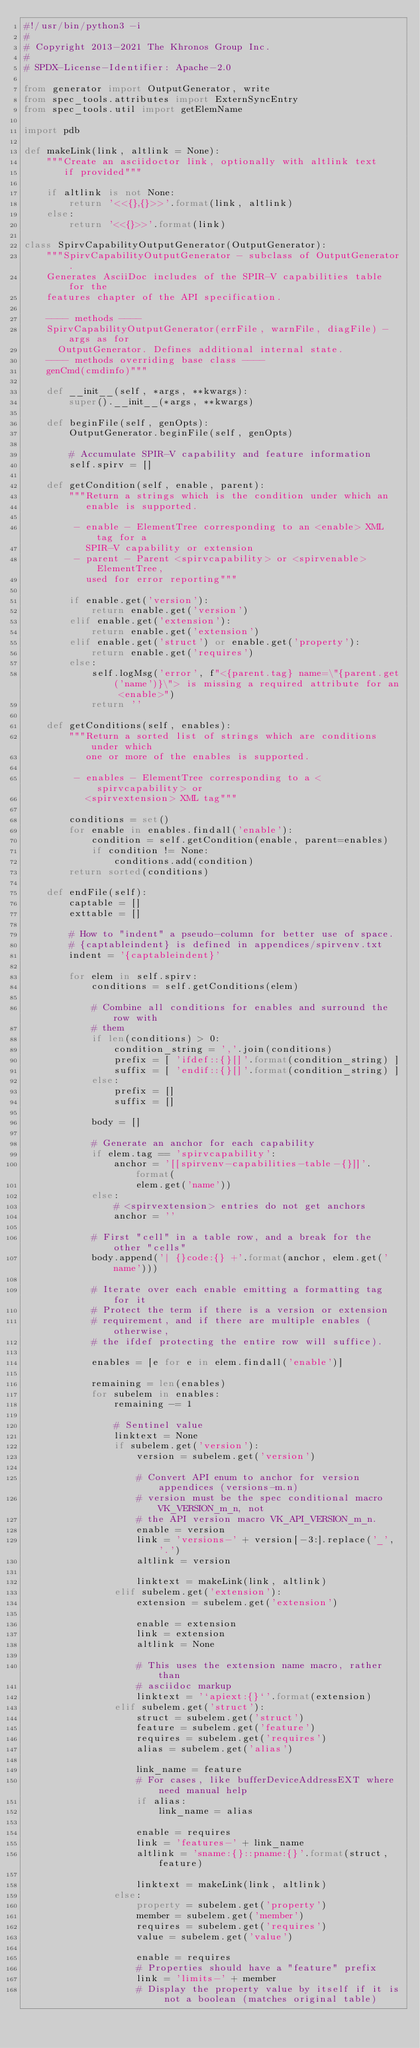Convert code to text. <code><loc_0><loc_0><loc_500><loc_500><_Python_>#!/usr/bin/python3 -i
#
# Copyright 2013-2021 The Khronos Group Inc.
#
# SPDX-License-Identifier: Apache-2.0

from generator import OutputGenerator, write
from spec_tools.attributes import ExternSyncEntry
from spec_tools.util import getElemName

import pdb

def makeLink(link, altlink = None):
    """Create an asciidoctor link, optionally with altlink text
       if provided"""

    if altlink is not None:
        return '<<{},{}>>'.format(link, altlink)
    else:
        return '<<{}>>'.format(link)

class SpirvCapabilityOutputGenerator(OutputGenerator):
    """SpirvCapabilityOutputGenerator - subclass of OutputGenerator.
    Generates AsciiDoc includes of the SPIR-V capabilities table for the
    features chapter of the API specification.

    ---- methods ----
    SpirvCapabilityOutputGenerator(errFile, warnFile, diagFile) - args as for
      OutputGenerator. Defines additional internal state.
    ---- methods overriding base class ----
    genCmd(cmdinfo)"""

    def __init__(self, *args, **kwargs):
        super().__init__(*args, **kwargs)

    def beginFile(self, genOpts):
        OutputGenerator.beginFile(self, genOpts)

        # Accumulate SPIR-V capability and feature information
        self.spirv = []

    def getCondition(self, enable, parent):
        """Return a strings which is the condition under which an
           enable is supported.

         - enable - ElementTree corresponding to an <enable> XML tag for a
           SPIR-V capability or extension
         - parent - Parent <spirvcapability> or <spirvenable> ElementTree,
           used for error reporting"""

        if enable.get('version'):
            return enable.get('version')
        elif enable.get('extension'):
            return enable.get('extension')
        elif enable.get('struct') or enable.get('property'):
            return enable.get('requires')
        else:
            self.logMsg('error', f"<{parent.tag} name=\"{parent.get('name')}\"> is missing a required attribute for an <enable>")
            return ''

    def getConditions(self, enables):
        """Return a sorted list of strings which are conditions under which
           one or more of the enables is supported.

         - enables - ElementTree corresponding to a <spirvcapability> or
           <spirvextension> XML tag"""

        conditions = set()
        for enable in enables.findall('enable'):
            condition = self.getCondition(enable, parent=enables)
            if condition != None:
                conditions.add(condition)
        return sorted(conditions)

    def endFile(self):
        captable = []
        exttable = []

        # How to "indent" a pseudo-column for better use of space.
        # {captableindent} is defined in appendices/spirvenv.txt
        indent = '{captableindent}'

        for elem in self.spirv:
            conditions = self.getConditions(elem)

            # Combine all conditions for enables and surround the row with
            # them
            if len(conditions) > 0:
                condition_string = ','.join(conditions)
                prefix = [ 'ifdef::{}[]'.format(condition_string) ]
                suffix = [ 'endif::{}[]'.format(condition_string) ]
            else:
                prefix = []
                suffix = []

            body = []

            # Generate an anchor for each capability
            if elem.tag == 'spirvcapability':
                anchor = '[[spirvenv-capabilities-table-{}]]'.format(
                    elem.get('name'))
            else:
                # <spirvextension> entries do not get anchors
                anchor = ''

            # First "cell" in a table row, and a break for the other "cells"
            body.append('| {}code:{} +'.format(anchor, elem.get('name')))

            # Iterate over each enable emitting a formatting tag for it
            # Protect the term if there is a version or extension
            # requirement, and if there are multiple enables (otherwise,
            # the ifdef protecting the entire row will suffice).

            enables = [e for e in elem.findall('enable')]

            remaining = len(enables)
            for subelem in enables:
                remaining -= 1

                # Sentinel value
                linktext = None
                if subelem.get('version'):
                    version = subelem.get('version')

                    # Convert API enum to anchor for version appendices (versions-m.n)
                    # version must be the spec conditional macro VK_VERSION_m_n, not
                    # the API version macro VK_API_VERSION_m_n.
                    enable = version
                    link = 'versions-' + version[-3:].replace('_', '.')
                    altlink = version

                    linktext = makeLink(link, altlink)
                elif subelem.get('extension'):
                    extension = subelem.get('extension')

                    enable = extension
                    link = extension
                    altlink = None

                    # This uses the extension name macro, rather than
                    # asciidoc markup
                    linktext = '`apiext:{}`'.format(extension)
                elif subelem.get('struct'):
                    struct = subelem.get('struct')
                    feature = subelem.get('feature')
                    requires = subelem.get('requires')
                    alias = subelem.get('alias')

                    link_name = feature
                    # For cases, like bufferDeviceAddressEXT where need manual help
                    if alias:
                        link_name = alias

                    enable = requires
                    link = 'features-' + link_name
                    altlink = 'sname:{}::pname:{}'.format(struct, feature)

                    linktext = makeLink(link, altlink)
                else:
                    property = subelem.get('property')
                    member = subelem.get('member')
                    requires = subelem.get('requires')
                    value = subelem.get('value')

                    enable = requires
                    # Properties should have a "feature" prefix
                    link = 'limits-' + member
                    # Display the property value by itself if it is not a boolean (matches original table)</code> 